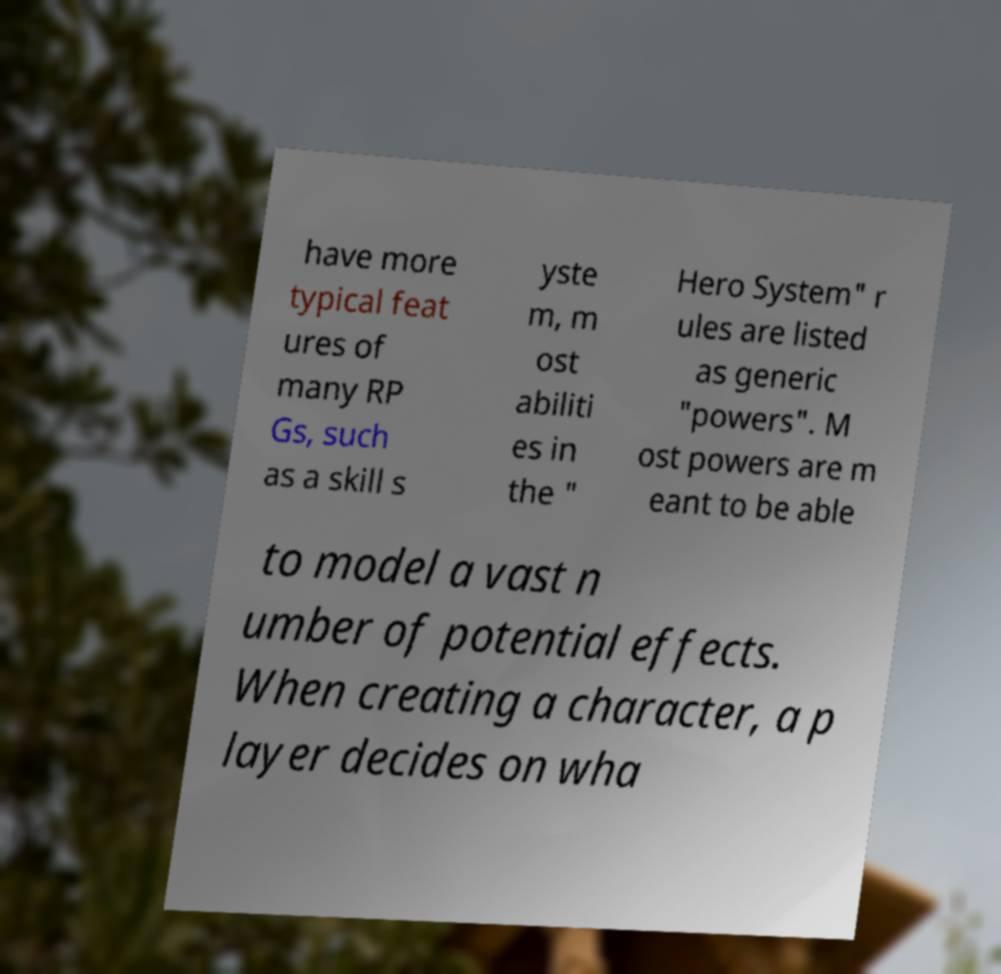Could you assist in decoding the text presented in this image and type it out clearly? have more typical feat ures of many RP Gs, such as a skill s yste m, m ost abiliti es in the " Hero System" r ules are listed as generic "powers". M ost powers are m eant to be able to model a vast n umber of potential effects. When creating a character, a p layer decides on wha 